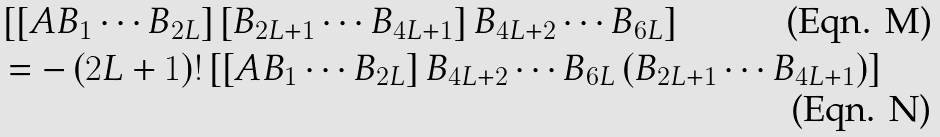Convert formula to latex. <formula><loc_0><loc_0><loc_500><loc_500>& \left [ \left [ A B _ { 1 } \cdots B _ { 2 L } \right ] \left [ B _ { 2 L + 1 } \cdots B _ { 4 L + 1 } \right ] B _ { 4 L + 2 } \cdots B _ { 6 L } \right ] \\ & = - \left ( 2 L + 1 \right ) ! \left [ \left [ A B _ { 1 } \cdots B _ { 2 L } \right ] B _ { 4 L + 2 } \cdots B _ { 6 L } \left ( B _ { 2 L + 1 } \cdots B _ { 4 L + 1 } \right ) \right ]</formula> 